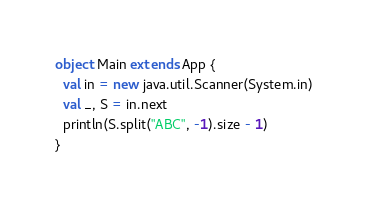<code> <loc_0><loc_0><loc_500><loc_500><_Scala_>object Main extends App {
  val in = new java.util.Scanner(System.in)
  val _, S = in.next
  println(S.split("ABC", -1).size - 1)
}</code> 